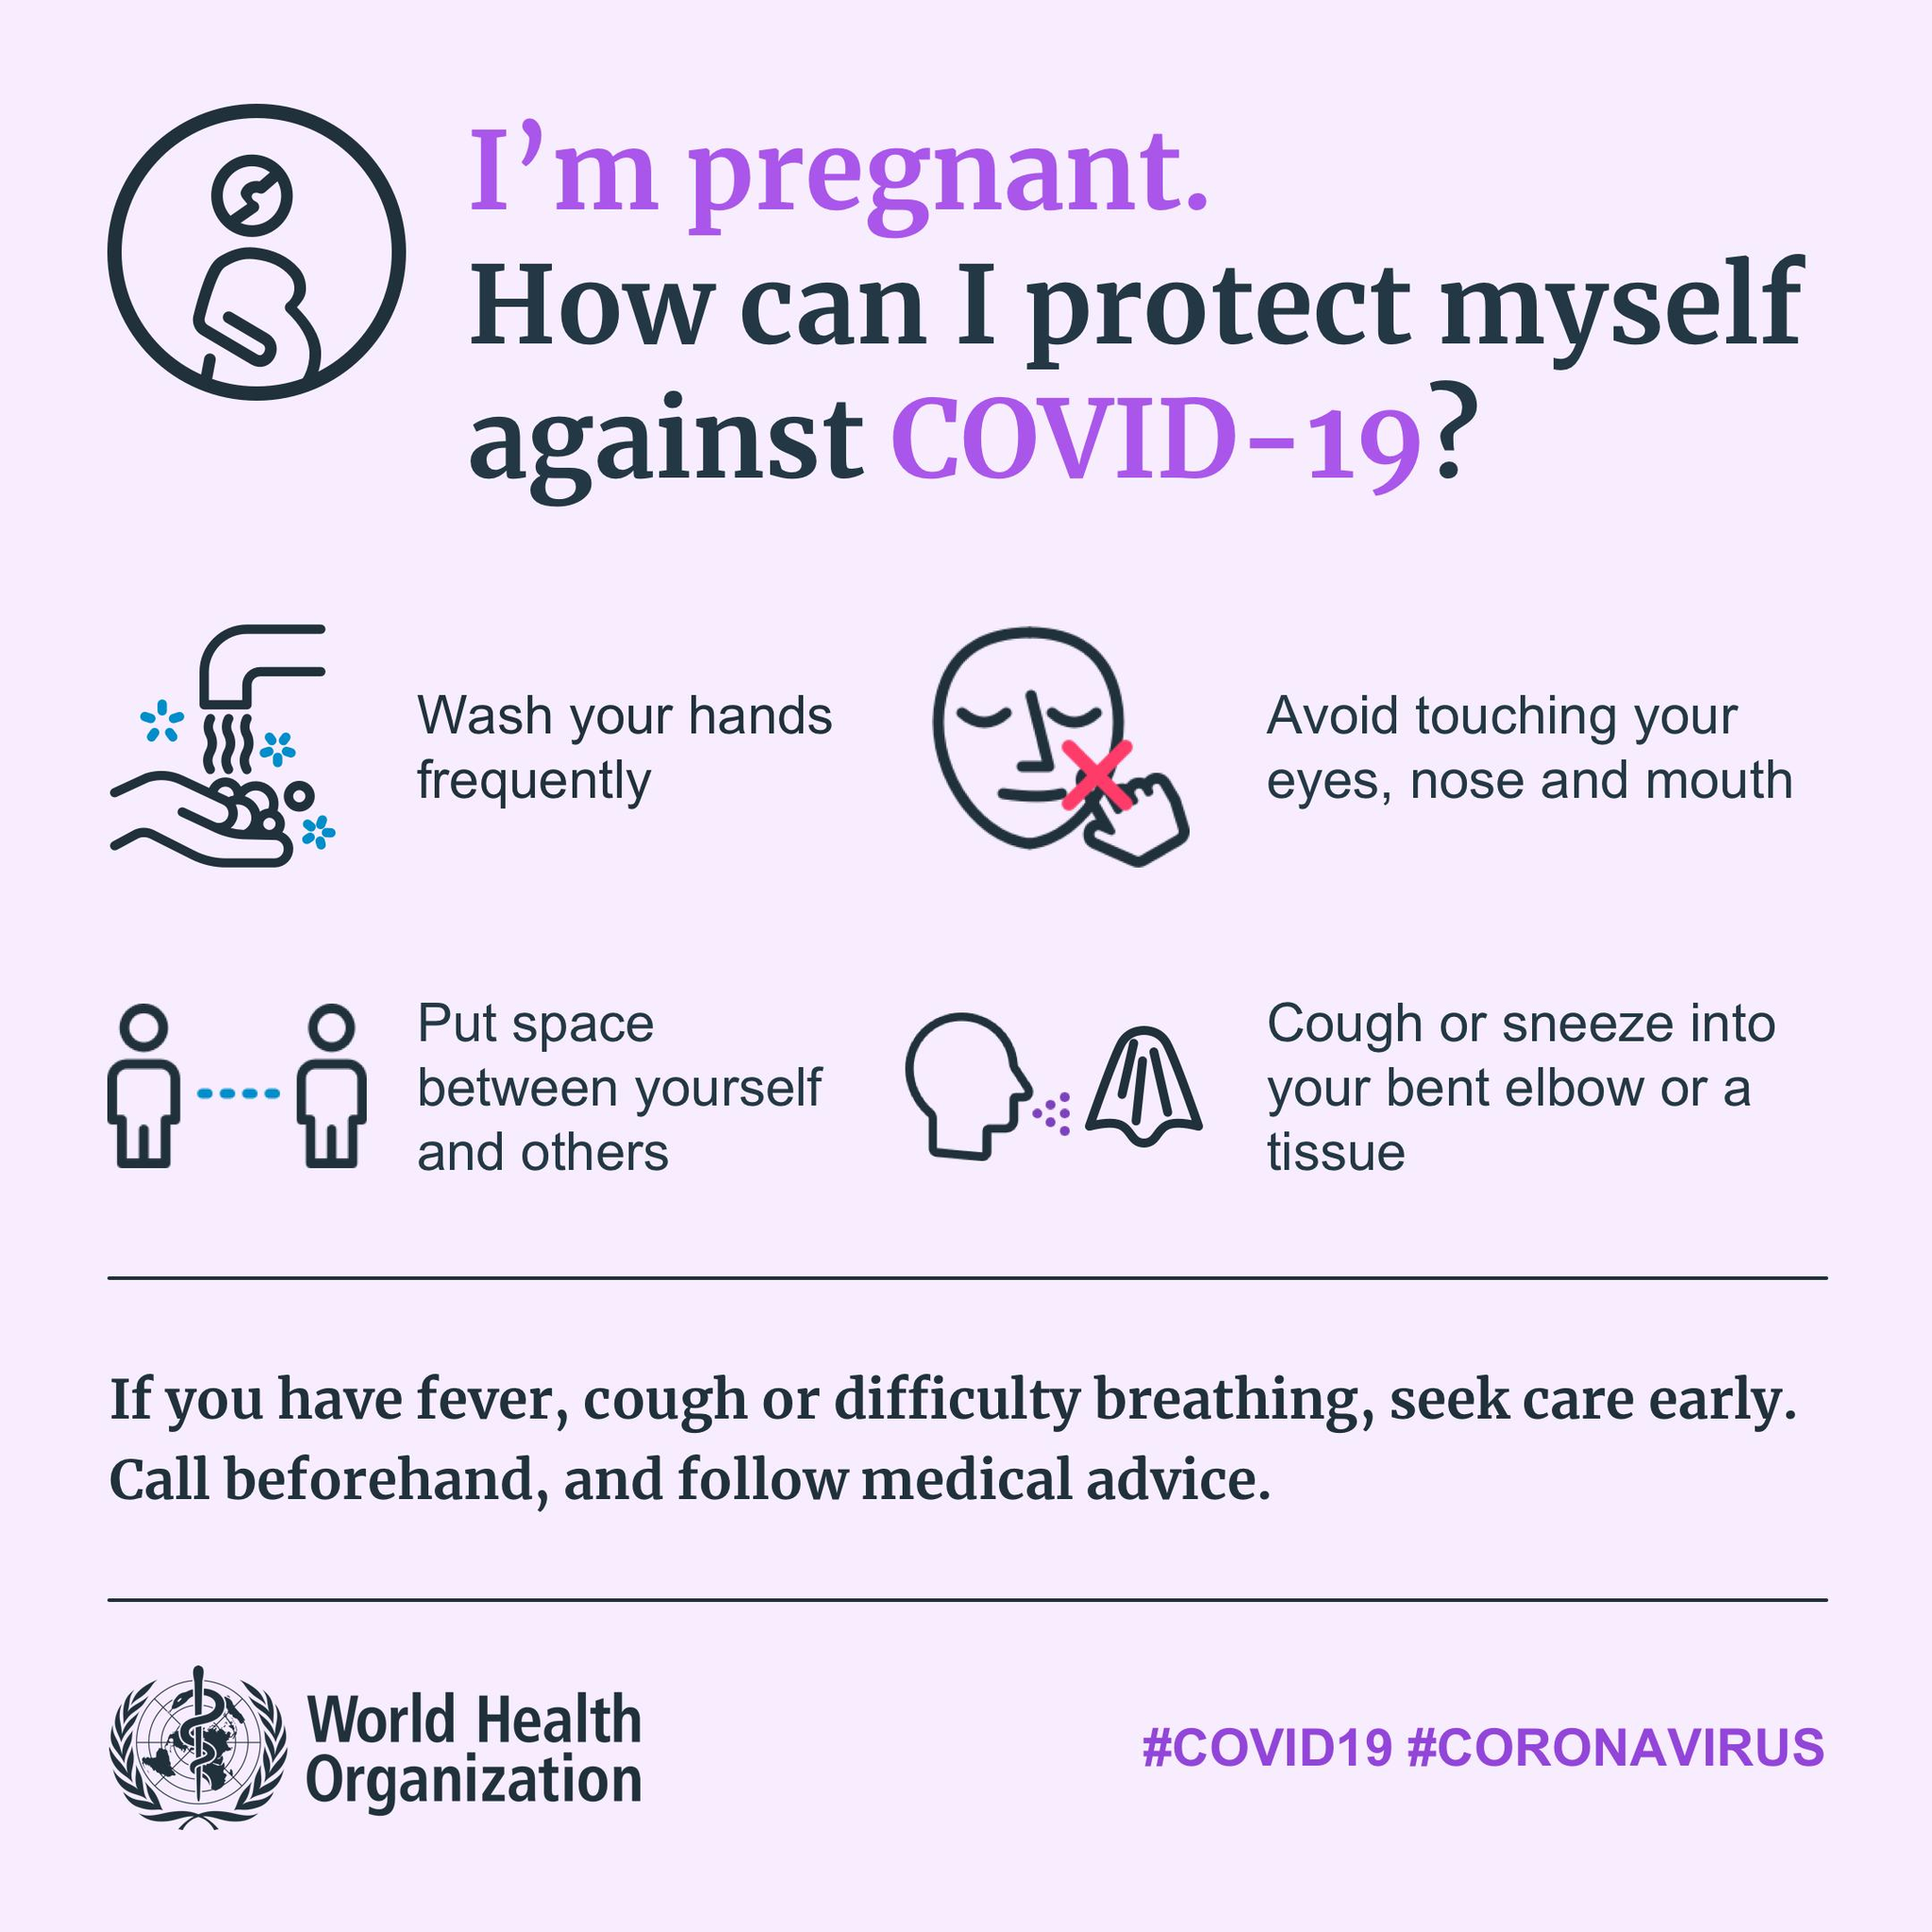Highlight a few significant elements in this photo. The hashtags mentioned are "#COVID19" and "#CORONAVIRUS". 